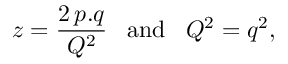<formula> <loc_0><loc_0><loc_500><loc_500>z = \frac { 2 \, p . q } { Q ^ { 2 } } \, a n d \, Q ^ { 2 } = q ^ { 2 } ,</formula> 